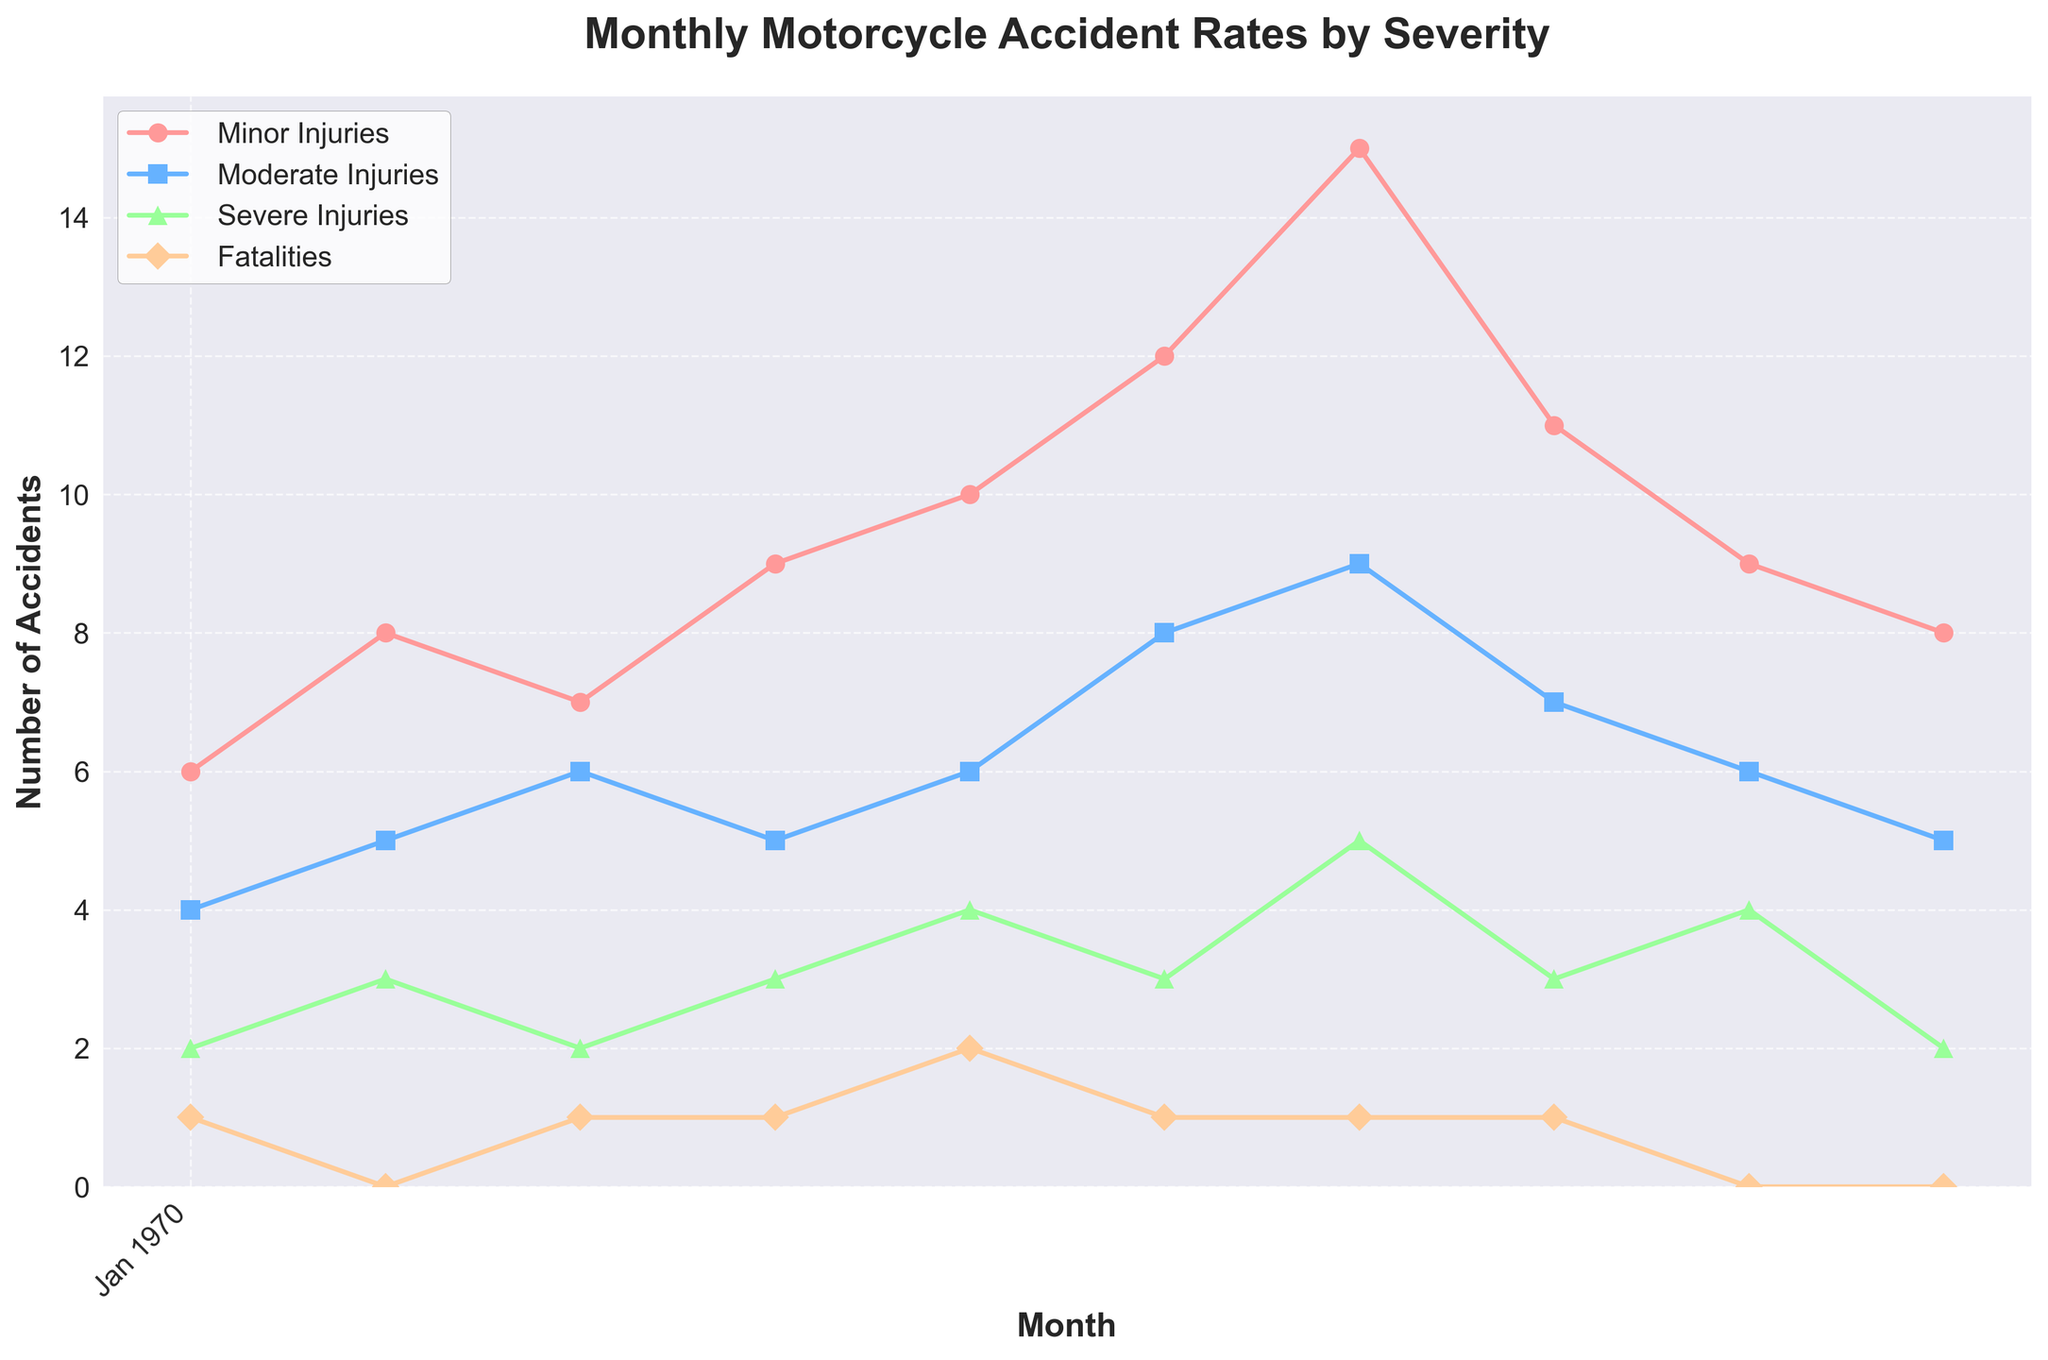What is the title of the figure? The title of the figure is displayed prominently at the top and summarizes the content being shown.
Answer: Monthly Motorcycle Accident Rates by Severity What is the highest number of Minor Injuries recorded in any month? By observing the data points for Minor Injuries, the highest number appears to be in July with 15 injuries.
Answer: 15 Which month had the most Fatalities? Reviewing the Fatalities line, we see that May had the highest number with 2 fatalities.
Answer: May How does the number of Severe Injuries in August compare to the number of Moderate Injuries in the same month? Checking both data points for August, Severe Injuries are 3 and Moderate Injuries are 7. Thus, Severe Injuries are fewer than Moderate Injuries.
Answer: Severe Injuries are fewer than Moderate Injuries What is the average number of Moderate Injuries from January to October? Adding the Moderate Injury data points (4 + 5 + 6 + 5 + 6 + 8 + 9 + 7 + 6 + 5) gives 61, and dividing by the number of months (10) results in an average of 6.1
Answer: 6.1 How many times were there no Fatalities in a month? By looking at the Fatalities line, there are 4 months with zero fatalities (February, September, and October).
Answer: 4 What trends can be observed for Minor Injuries throughout the year? Observing the Minor Injuries line shows a generally increasing trend from January (6) to July (15), then a decline towards October (8).
Answer: Increasing then decreasing Which month saw an equal number of Severe Injuries and Fatalities? By comparing Severe Injuries and Fatalities for each month, in April, both were equal to 3 and 1 respectively.
Answer: April What is the total number of Minor Injuries and Severe Injuries combined in June? Summing Minor Injuries (12) and Severe Injuries (3) for June results in 15 total injuries.
Answer: 15 Which injury type saw the most significant increase from one month to the next? Comparing month-to-month changes, Minor Injuries jumped by 3 from June (12) to July (15), which is the most significant observed increase.
Answer: Minor Injuries from June to July 